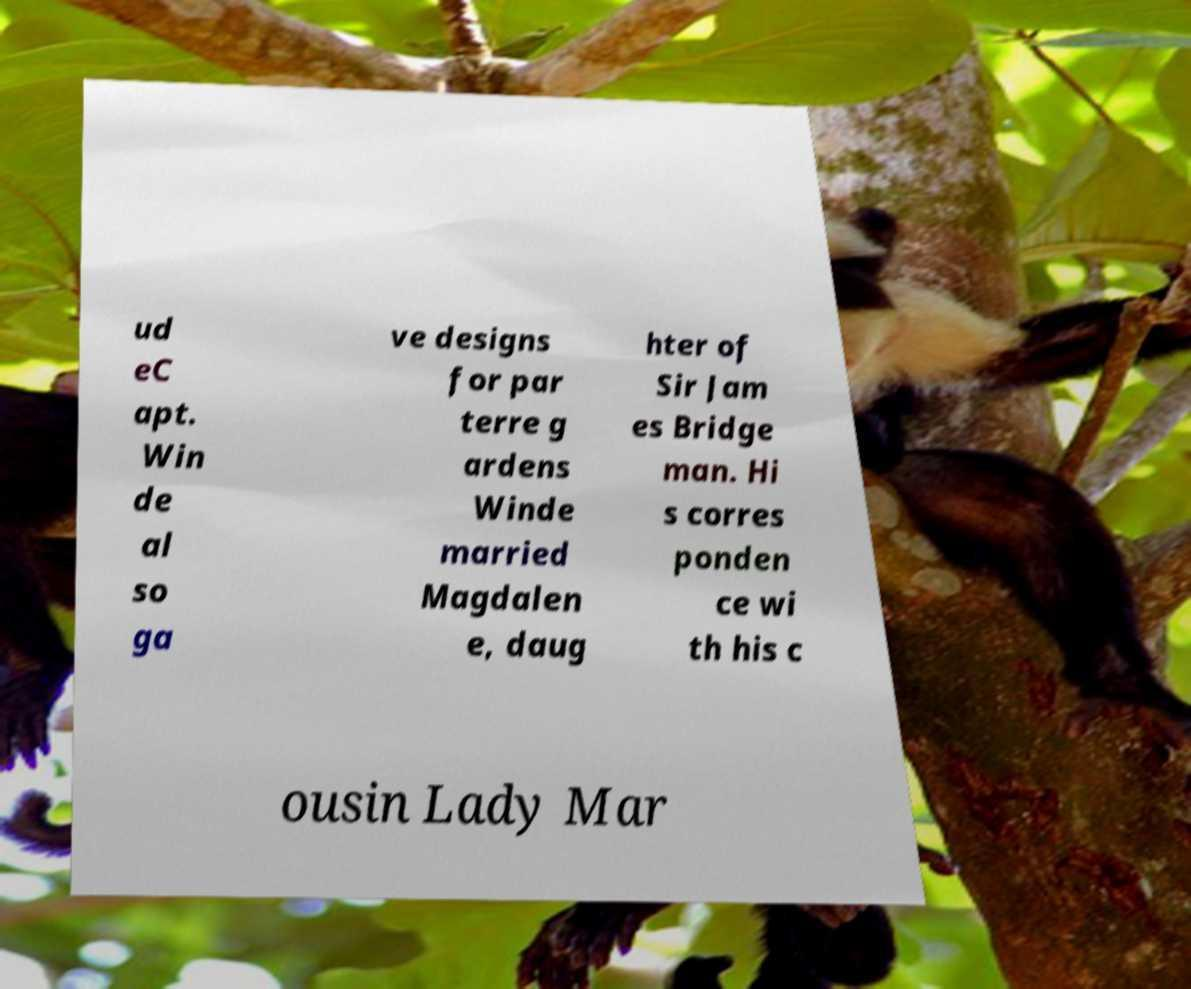Can you accurately transcribe the text from the provided image for me? ud eC apt. Win de al so ga ve designs for par terre g ardens Winde married Magdalen e, daug hter of Sir Jam es Bridge man. Hi s corres ponden ce wi th his c ousin Lady Mar 